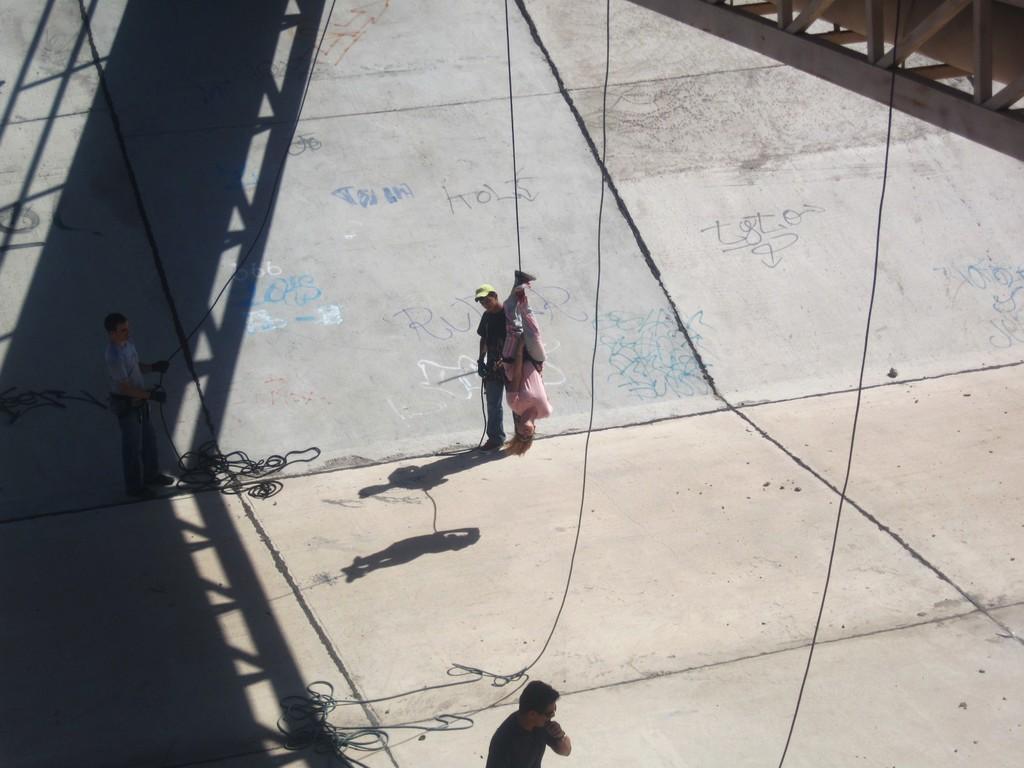Describe this image in one or two sentences. Here in this picture we can see a group of men standing over a place and we can see one person hanging in the air with the help of rope, as we can see ropes present and hanging all over there and above them we can see a bridge present, as we can see a shadow of it on the ground. 